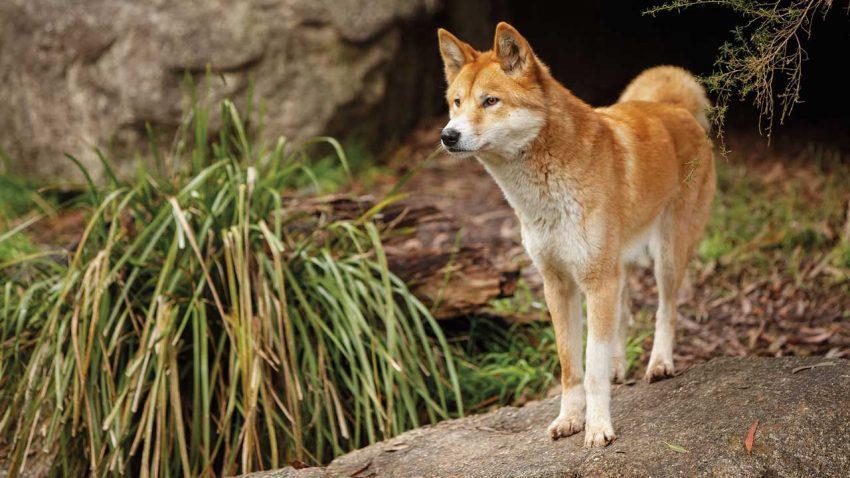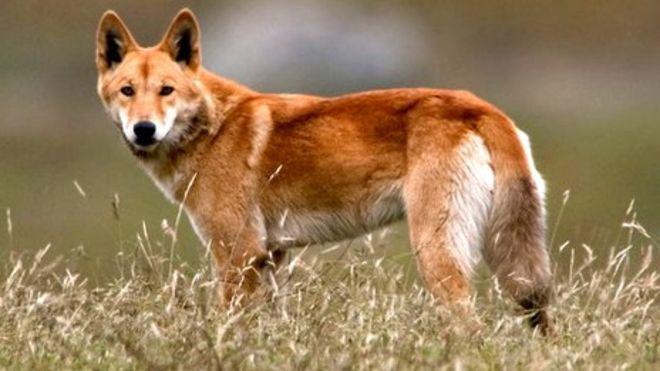The first image is the image on the left, the second image is the image on the right. Analyze the images presented: Is the assertion "At least one dog has its teeth visible." valid? Answer yes or no. No. 